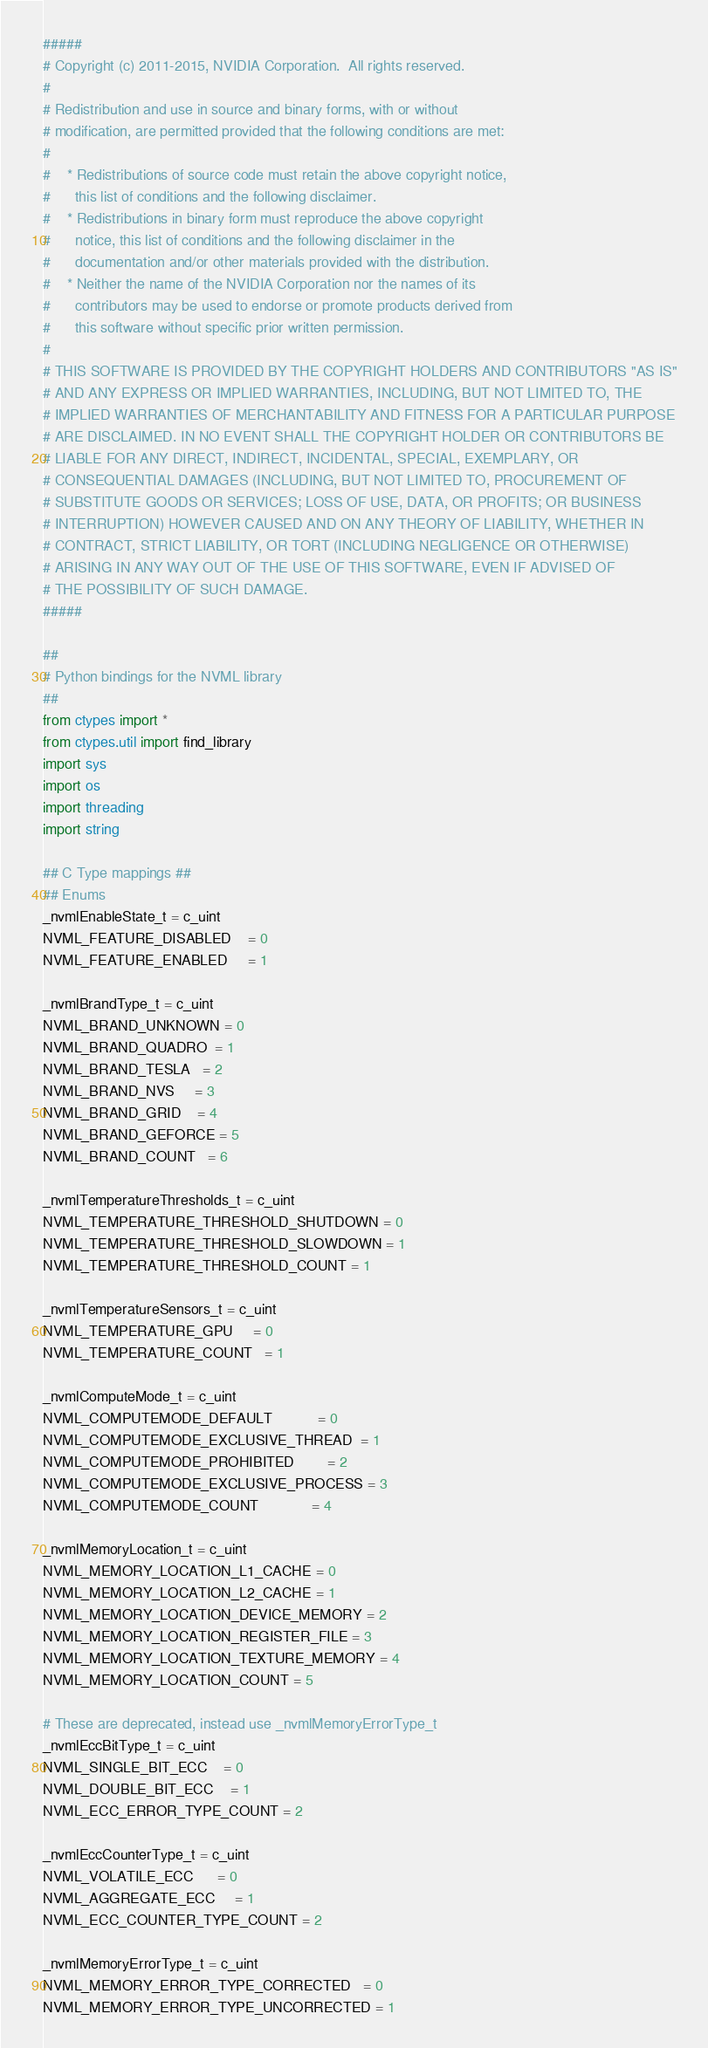<code> <loc_0><loc_0><loc_500><loc_500><_Python_>#####
# Copyright (c) 2011-2015, NVIDIA Corporation.  All rights reserved.
#
# Redistribution and use in source and binary forms, with or without
# modification, are permitted provided that the following conditions are met:
#
#    * Redistributions of source code must retain the above copyright notice,
#      this list of conditions and the following disclaimer.
#    * Redistributions in binary form must reproduce the above copyright
#      notice, this list of conditions and the following disclaimer in the
#      documentation and/or other materials provided with the distribution.
#    * Neither the name of the NVIDIA Corporation nor the names of its
#      contributors may be used to endorse or promote products derived from
#      this software without specific prior written permission.
#
# THIS SOFTWARE IS PROVIDED BY THE COPYRIGHT HOLDERS AND CONTRIBUTORS "AS IS"
# AND ANY EXPRESS OR IMPLIED WARRANTIES, INCLUDING, BUT NOT LIMITED TO, THE
# IMPLIED WARRANTIES OF MERCHANTABILITY AND FITNESS FOR A PARTICULAR PURPOSE
# ARE DISCLAIMED. IN NO EVENT SHALL THE COPYRIGHT HOLDER OR CONTRIBUTORS BE
# LIABLE FOR ANY DIRECT, INDIRECT, INCIDENTAL, SPECIAL, EXEMPLARY, OR
# CONSEQUENTIAL DAMAGES (INCLUDING, BUT NOT LIMITED TO, PROCUREMENT OF
# SUBSTITUTE GOODS OR SERVICES; LOSS OF USE, DATA, OR PROFITS; OR BUSINESS
# INTERRUPTION) HOWEVER CAUSED AND ON ANY THEORY OF LIABILITY, WHETHER IN
# CONTRACT, STRICT LIABILITY, OR TORT (INCLUDING NEGLIGENCE OR OTHERWISE)
# ARISING IN ANY WAY OUT OF THE USE OF THIS SOFTWARE, EVEN IF ADVISED OF
# THE POSSIBILITY OF SUCH DAMAGE.
#####

##
# Python bindings for the NVML library
##
from ctypes import *
from ctypes.util import find_library
import sys
import os
import threading
import string

## C Type mappings ##
## Enums
_nvmlEnableState_t = c_uint
NVML_FEATURE_DISABLED    = 0
NVML_FEATURE_ENABLED     = 1

_nvmlBrandType_t = c_uint
NVML_BRAND_UNKNOWN = 0
NVML_BRAND_QUADRO  = 1
NVML_BRAND_TESLA   = 2
NVML_BRAND_NVS     = 3
NVML_BRAND_GRID    = 4
NVML_BRAND_GEFORCE = 5
NVML_BRAND_COUNT   = 6

_nvmlTemperatureThresholds_t = c_uint
NVML_TEMPERATURE_THRESHOLD_SHUTDOWN = 0
NVML_TEMPERATURE_THRESHOLD_SLOWDOWN = 1
NVML_TEMPERATURE_THRESHOLD_COUNT = 1

_nvmlTemperatureSensors_t = c_uint
NVML_TEMPERATURE_GPU     = 0
NVML_TEMPERATURE_COUNT   = 1

_nvmlComputeMode_t = c_uint
NVML_COMPUTEMODE_DEFAULT           = 0
NVML_COMPUTEMODE_EXCLUSIVE_THREAD  = 1
NVML_COMPUTEMODE_PROHIBITED        = 2
NVML_COMPUTEMODE_EXCLUSIVE_PROCESS = 3
NVML_COMPUTEMODE_COUNT             = 4

_nvmlMemoryLocation_t = c_uint
NVML_MEMORY_LOCATION_L1_CACHE = 0
NVML_MEMORY_LOCATION_L2_CACHE = 1
NVML_MEMORY_LOCATION_DEVICE_MEMORY = 2
NVML_MEMORY_LOCATION_REGISTER_FILE = 3
NVML_MEMORY_LOCATION_TEXTURE_MEMORY = 4
NVML_MEMORY_LOCATION_COUNT = 5

# These are deprecated, instead use _nvmlMemoryErrorType_t
_nvmlEccBitType_t = c_uint
NVML_SINGLE_BIT_ECC    = 0
NVML_DOUBLE_BIT_ECC    = 1
NVML_ECC_ERROR_TYPE_COUNT = 2

_nvmlEccCounterType_t = c_uint
NVML_VOLATILE_ECC      = 0
NVML_AGGREGATE_ECC     = 1
NVML_ECC_COUNTER_TYPE_COUNT = 2

_nvmlMemoryErrorType_t = c_uint
NVML_MEMORY_ERROR_TYPE_CORRECTED   = 0
NVML_MEMORY_ERROR_TYPE_UNCORRECTED = 1</code> 